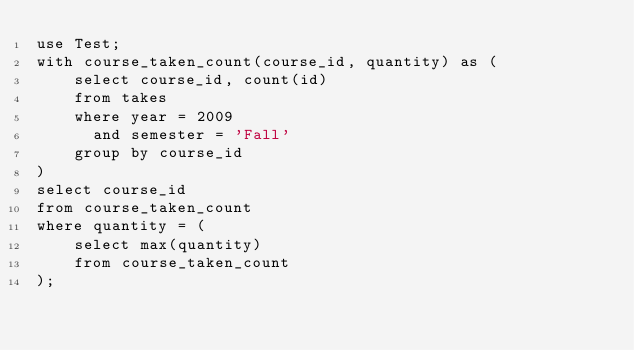Convert code to text. <code><loc_0><loc_0><loc_500><loc_500><_SQL_>use Test;
with course_taken_count(course_id, quantity) as (
    select course_id, count(id)
    from takes
    where year = 2009
      and semester = 'Fall'
    group by course_id
)
select course_id
from course_taken_count
where quantity = (
    select max(quantity)
    from course_taken_count
);</code> 